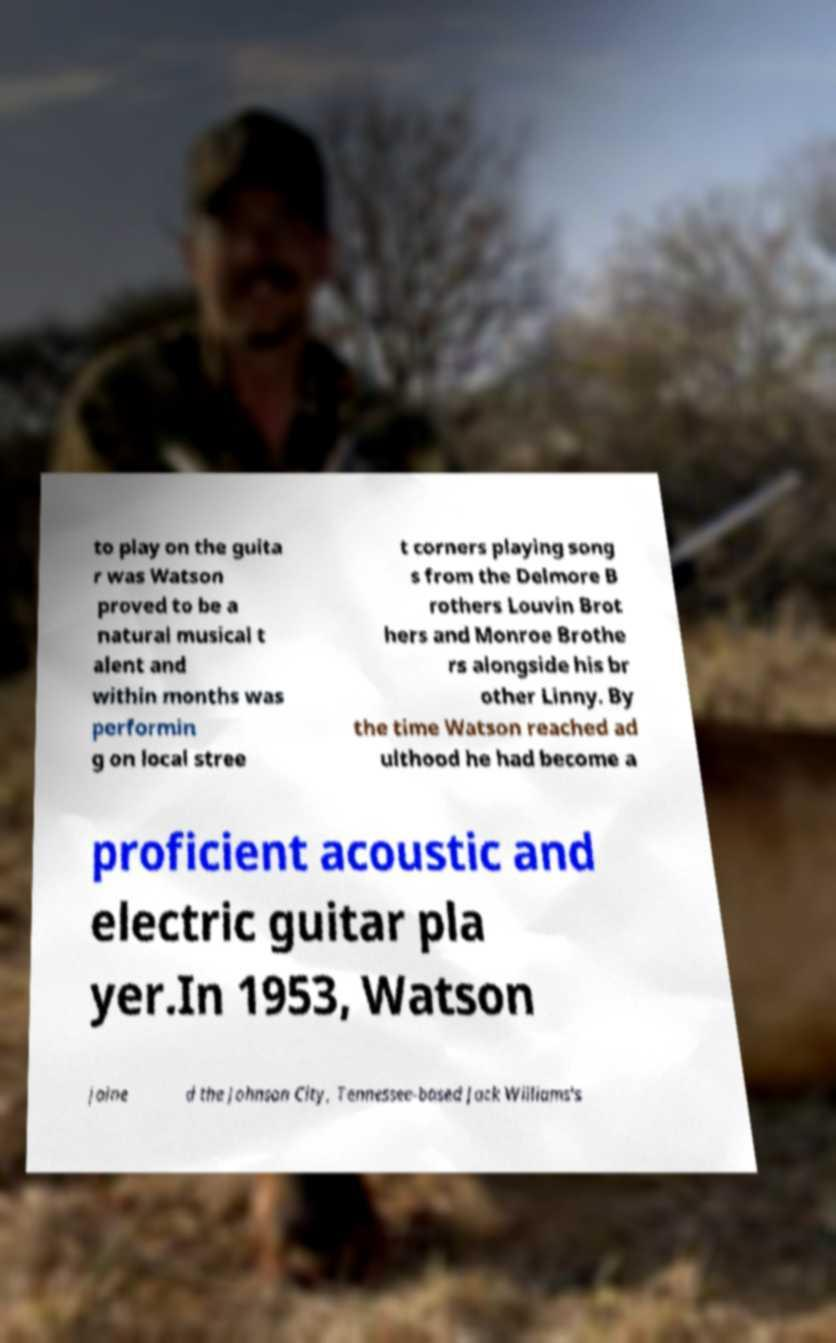Can you accurately transcribe the text from the provided image for me? to play on the guita r was Watson proved to be a natural musical t alent and within months was performin g on local stree t corners playing song s from the Delmore B rothers Louvin Brot hers and Monroe Brothe rs alongside his br other Linny. By the time Watson reached ad ulthood he had become a proficient acoustic and electric guitar pla yer.In 1953, Watson joine d the Johnson City, Tennessee-based Jack Williams's 